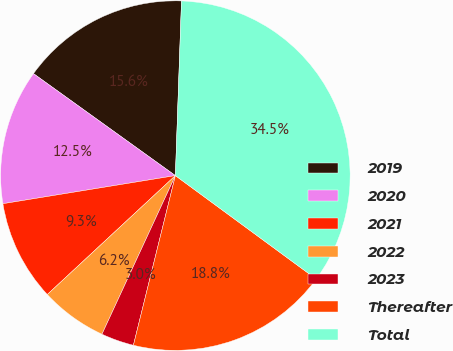<chart> <loc_0><loc_0><loc_500><loc_500><pie_chart><fcel>2019<fcel>2020<fcel>2021<fcel>2022<fcel>2023<fcel>Thereafter<fcel>Total<nl><fcel>15.64%<fcel>12.49%<fcel>9.34%<fcel>6.19%<fcel>3.04%<fcel>18.78%<fcel>34.53%<nl></chart> 